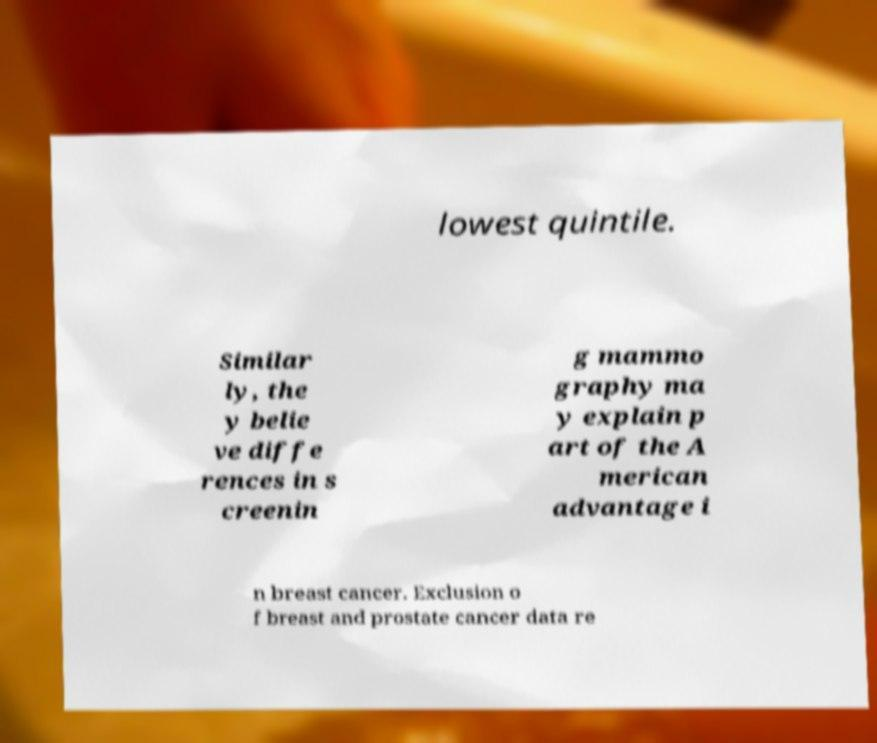Please read and relay the text visible in this image. What does it say? lowest quintile. Similar ly, the y belie ve diffe rences in s creenin g mammo graphy ma y explain p art of the A merican advantage i n breast cancer. Exclusion o f breast and prostate cancer data re 